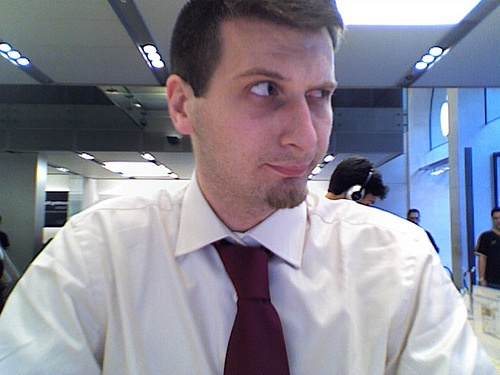Describe the objects in this image and their specific colors. I can see people in gray, lightgray, darkgray, and black tones, tie in gray, black, and purple tones, people in gray and black tones, people in gray, black, and navy tones, and people in gray, black, navy, and blue tones in this image. 